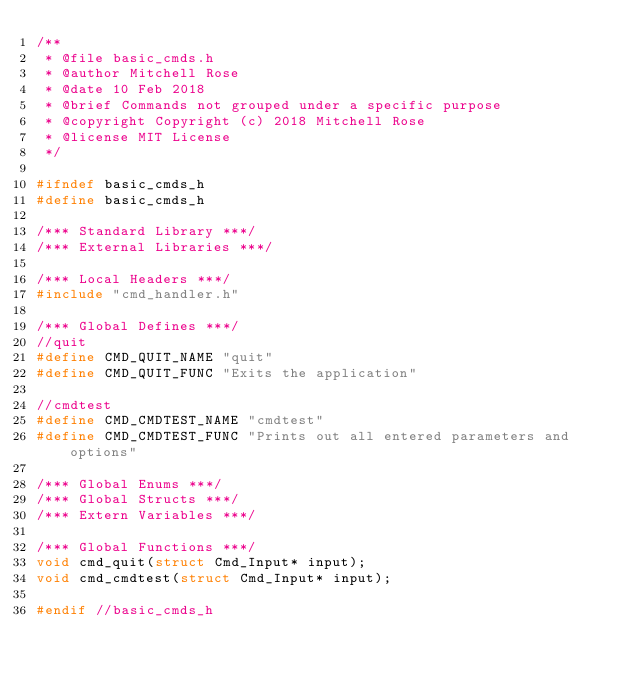<code> <loc_0><loc_0><loc_500><loc_500><_C_>/**
 * @file basic_cmds.h
 * @author Mitchell Rose
 * @date 10 Feb 2018
 * @brief Commands not grouped under a specific purpose
 * @copyright Copyright (c) 2018 Mitchell Rose
 * @license MIT License
 */

#ifndef basic_cmds_h
#define basic_cmds_h

/*** Standard Library ***/
/*** External Libraries ***/

/*** Local Headers ***/
#include "cmd_handler.h"

/*** Global Defines ***/
//quit
#define CMD_QUIT_NAME "quit"
#define CMD_QUIT_FUNC "Exits the application"

//cmdtest
#define CMD_CMDTEST_NAME "cmdtest"
#define CMD_CMDTEST_FUNC "Prints out all entered parameters and options"

/*** Global Enums ***/
/*** Global Structs ***/
/*** Extern Variables ***/

/*** Global Functions ***/
void cmd_quit(struct Cmd_Input* input);
void cmd_cmdtest(struct Cmd_Input* input);

#endif //basic_cmds_h
</code> 